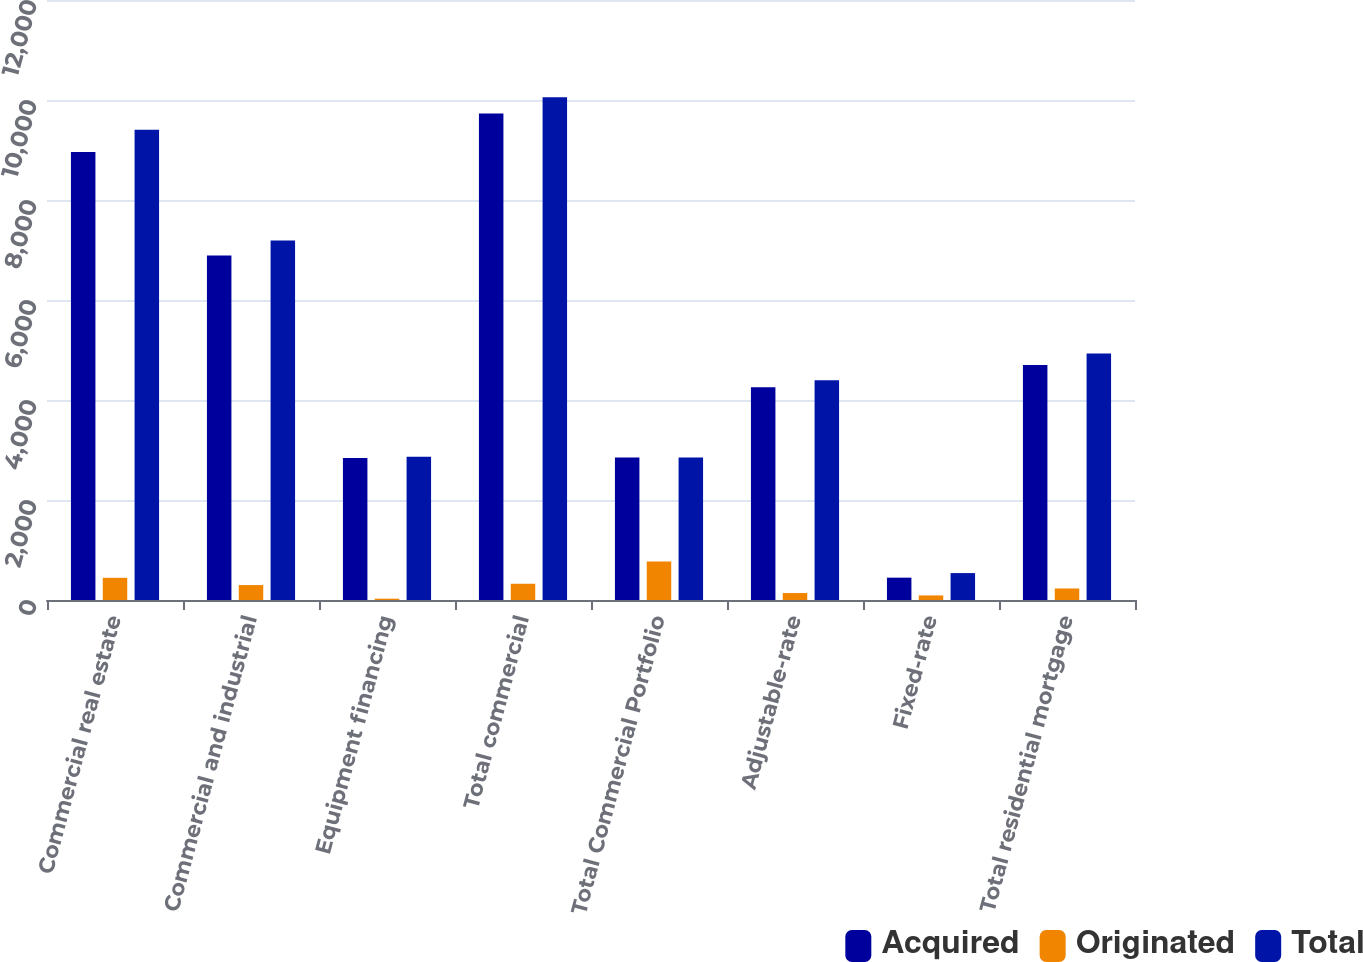<chart> <loc_0><loc_0><loc_500><loc_500><stacked_bar_chart><ecel><fcel>Commercial real estate<fcel>Commercial and industrial<fcel>Equipment financing<fcel>Total commercial<fcel>Total Commercial Portfolio<fcel>Adjustable-rate<fcel>Fixed-rate<fcel>Total residential mortgage<nl><fcel>Acquired<fcel>8960.3<fcel>6891.1<fcel>2839<fcel>9730.1<fcel>2852.25<fcel>4254.7<fcel>446.8<fcel>4701.5<nl><fcel>Originated<fcel>444<fcel>298.5<fcel>26.5<fcel>325<fcel>769<fcel>139.1<fcel>91.4<fcel>230.5<nl><fcel>Total<fcel>9404.3<fcel>7189.6<fcel>2865.5<fcel>10055.1<fcel>2852.25<fcel>4393.8<fcel>538.2<fcel>4932<nl></chart> 